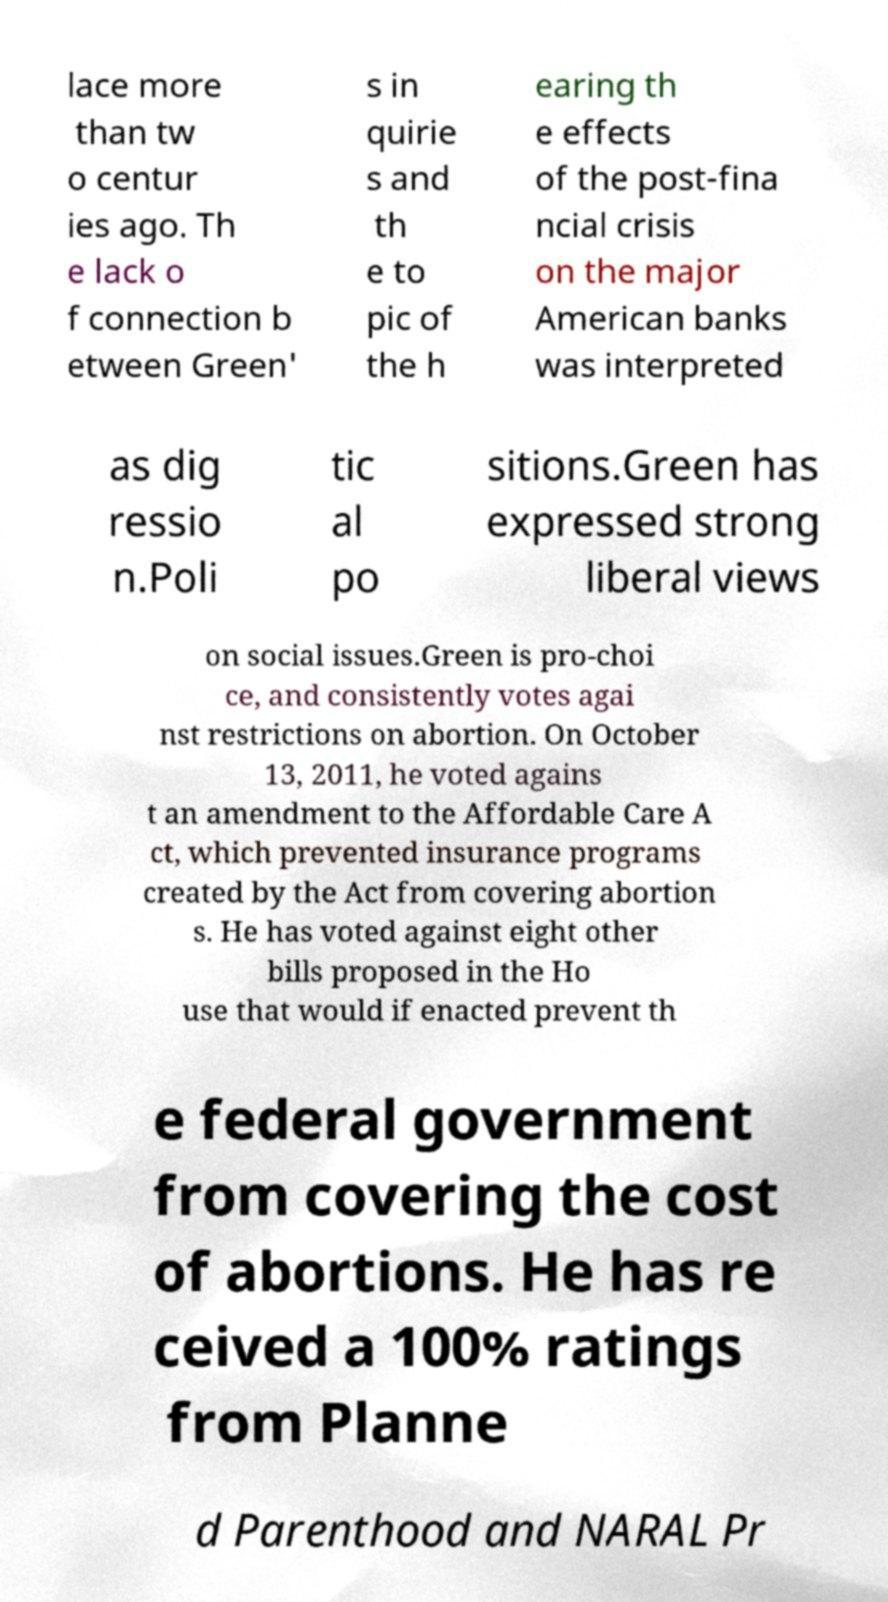Could you extract and type out the text from this image? lace more than tw o centur ies ago. Th e lack o f connection b etween Green' s in quirie s and th e to pic of the h earing th e effects of the post-fina ncial crisis on the major American banks was interpreted as dig ressio n.Poli tic al po sitions.Green has expressed strong liberal views on social issues.Green is pro-choi ce, and consistently votes agai nst restrictions on abortion. On October 13, 2011, he voted agains t an amendment to the Affordable Care A ct, which prevented insurance programs created by the Act from covering abortion s. He has voted against eight other bills proposed in the Ho use that would if enacted prevent th e federal government from covering the cost of abortions. He has re ceived a 100% ratings from Planne d Parenthood and NARAL Pr 